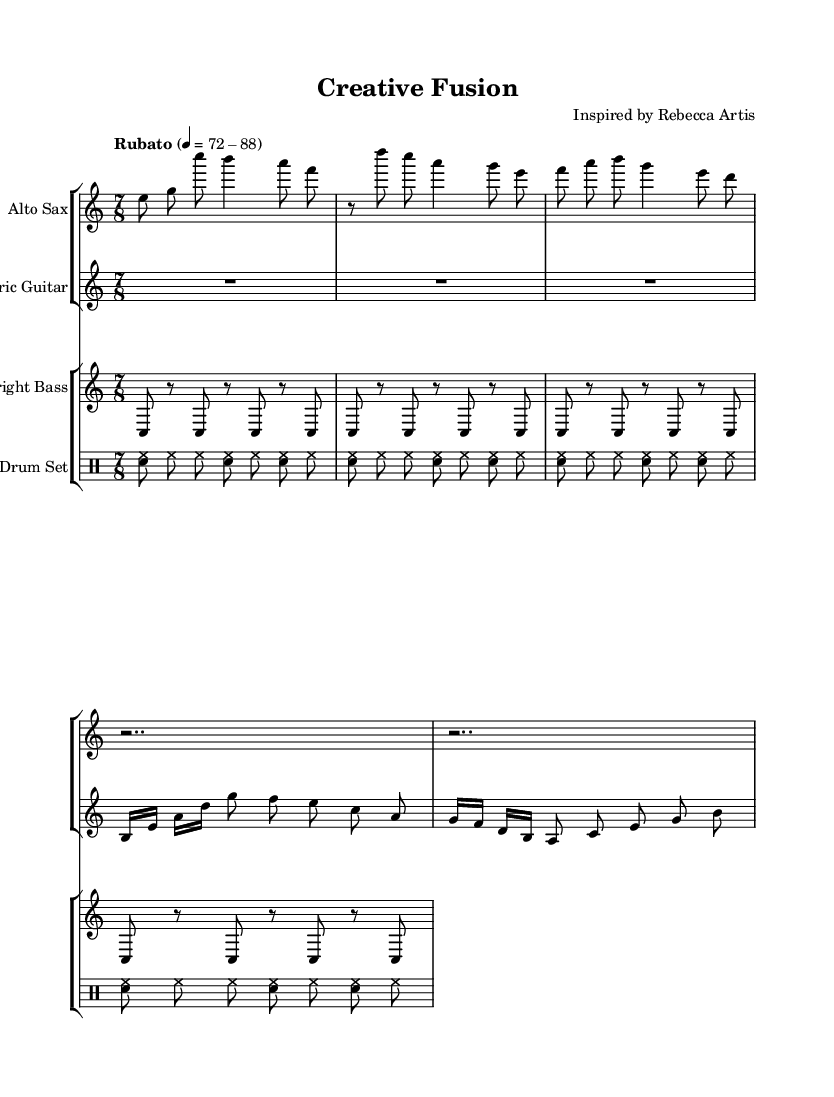What is the time signature of this music? The time signature, shown at the beginning, is 7/8, indicating that there are seven eighth-note beats in each measure.
Answer: 7/8 What is the tempo marking indicated in the score? The tempo marking at the beginning indicates "Rubato" with a range of 72-88 beats per minute, suggesting a flexible pacing in performance.
Answer: Rubato 4 = 72-88 Identify the principal instruments used in this piece. The score lists four main instruments: Alto Sax, Electric Guitar, Upright Bass, and Drum Set. These are indicated at the start of each staff.
Answer: Alto Sax, Electric Guitar, Upright Bass, Drum Set How many measures are shown in the intro for the alto saxophone? The intro for the alto saxophone consists of one measure, which contains the notes e, g, c', b, a, and f. This can be counted as the first measure in the provided part.
Answer: 1 Describe the rhythmic pattern used by the upright bass. The upright bass part features a repeated syncopated pattern of c and rests, alternating with eighth notes, which contributes to the overall groove of the piece.
Answer: Syncopated pattern of c and rests Which thematic section follows the introduction for the alto saxophone? After the introduction, the alto saxophone transitions into "Theme A," which is marked in the score and begins with a rest followed by a series of notes d', c, a, g, and e.
Answer: Theme A 